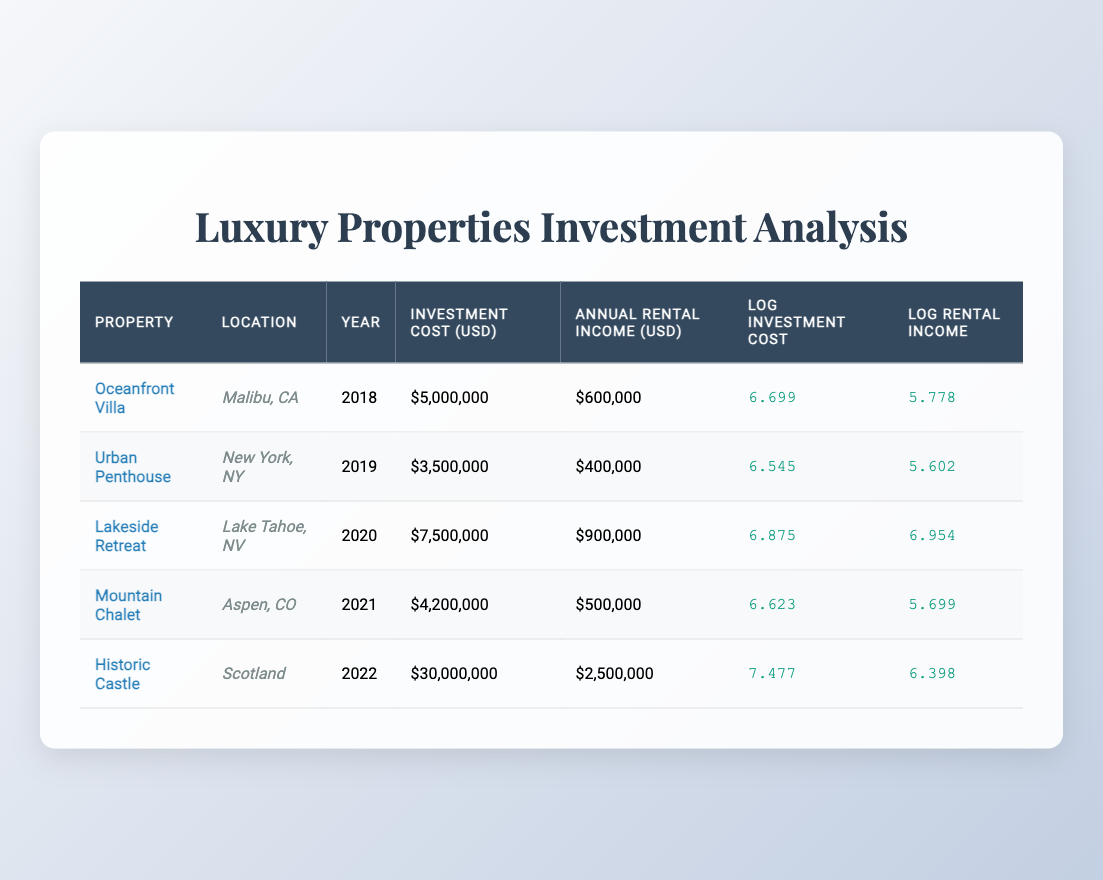What is the investment cost of the Historic Castle? The investment cost for the Historic Castle listed in the table is $30,000,000. It is found in the corresponding row under the Investment Cost (USD) column.
Answer: $30,000,000 What is the annual rental income for the Lakeside Retreat? The annual rental income for the Lakeside Retreat is $900,000, which can be found directly in the same row under the Annual Rental Income (USD) column.
Answer: $900,000 Which property has the highest log investment cost? To find the highest log investment cost, compare the values in the Log Investment Cost column. The Historic Castle has the highest log investment cost at 7.477.
Answer: Historic Castle What is the average annual rental income of the properties listed? To find the average, sum the annual rental incomes of all properties: $600,000 + $400,000 + $900,000 + $500,000 + $2,500,000 = $4,900,000. There are 5 properties, so the average is $4,900,000 / 5 = $980,000.
Answer: $980,000 Is the investment cost of the Oceanfront Villa greater than 4 million dollars? Comparing the investment cost of the Oceanfront Villa, which is $5,000,000, to 4 million, we find that it is indeed greater.
Answer: Yes Which property shows the highest ratio of annual rental income to investment cost? To find the highest ratio, calculate the rental income to investment cost for each property: Oceanfront Villa: 0.12, Urban Penthouse: 0.11, Lakeside Retreat: 0.12, Mountain Chalet: 0.12, Historic Castle: 0.083. The Oceanfront Villa, Lakeside Retreat, and Mountain Chalet show the highest ratio of 0.12.
Answer: Oceanfront Villa, Lakeside Retreat, Mountain Chalet What log value represents the annual rental income for the Urban Penthouse? Looking at the table, the Log Rental Income for the Urban Penthouse is logged as 5.602. This is found directly in the corresponding row of the Log Rental Income column.
Answer: 5.602 How many properties have an investment cost greater than 5 million dollars? To determine how many properties exceed an investment cost of $5,000,000, we look at the Investment Cost column. The Lakeside Retreat ($7,500,000), Mountain Chalet ($4,200,000), and Historic Castle ($30,000,000) are considered. So there are three properties that exceed the amount.
Answer: 3 Which property has the highest annual rental income and what is the value? The highest annual rental income is associated with the Historic Castle, which generates $2,500,000 per year. This is obtained from the Annual Rental Income (USD) column in the respective row.
Answer: Historic Castle, $2,500,000 